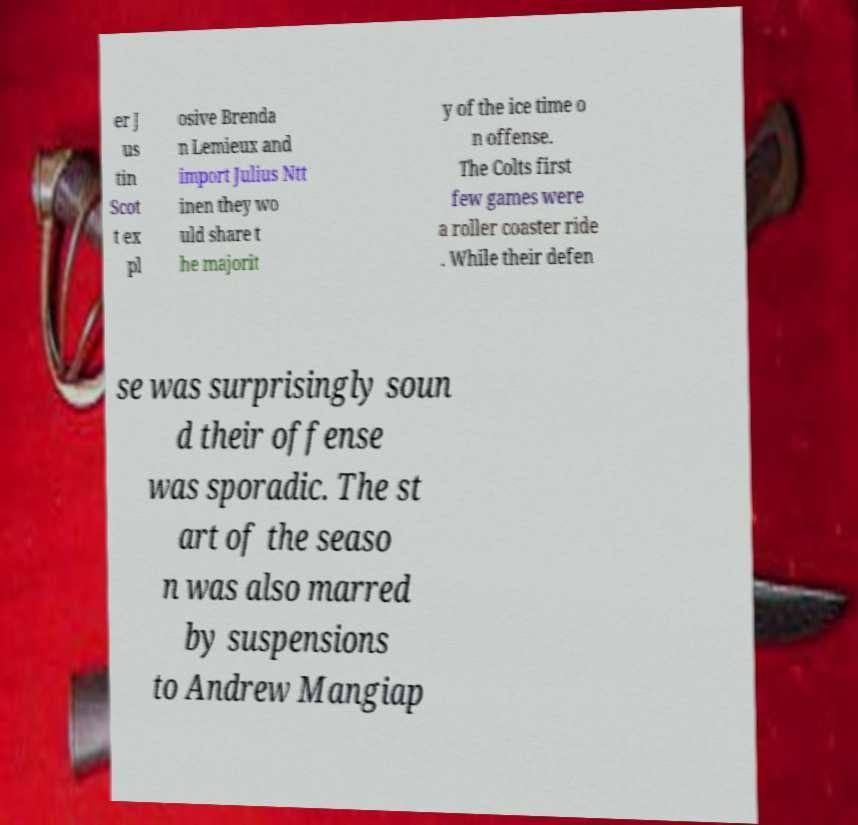Could you extract and type out the text from this image? er J us tin Scot t ex pl osive Brenda n Lemieux and import Julius Ntt inen they wo uld share t he majorit y of the ice time o n offense. The Colts first few games were a roller coaster ride . While their defen se was surprisingly soun d their offense was sporadic. The st art of the seaso n was also marred by suspensions to Andrew Mangiap 